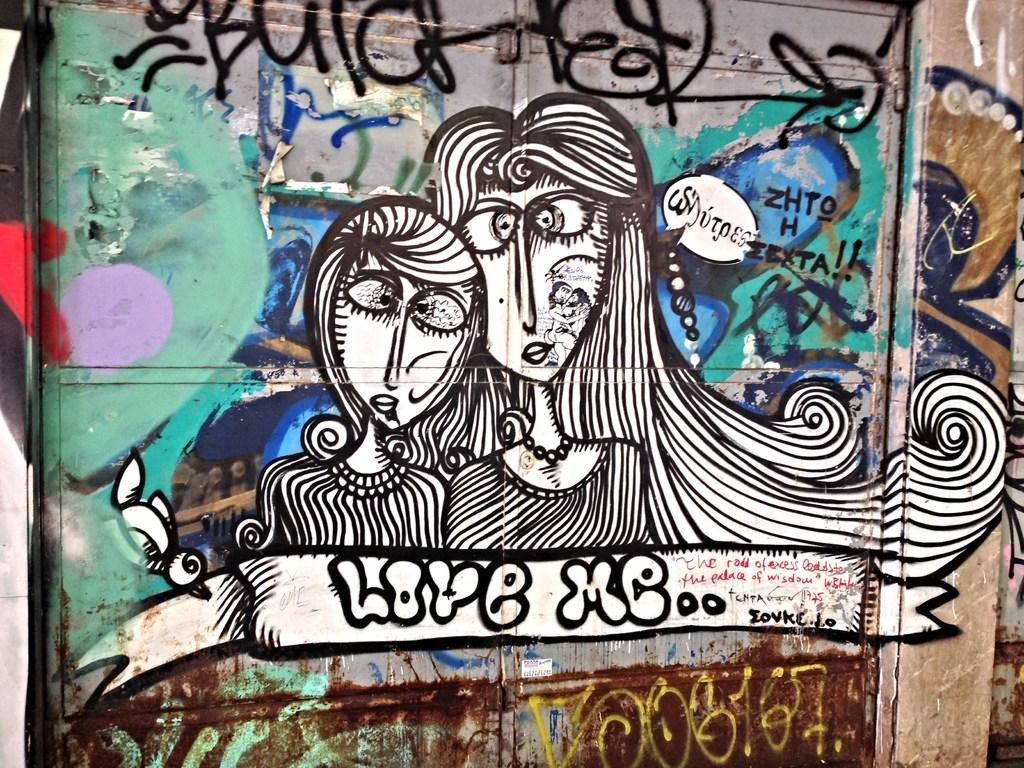How would you summarize this image in a sentence or two? In this image there is a graffiti painting on the wall. 